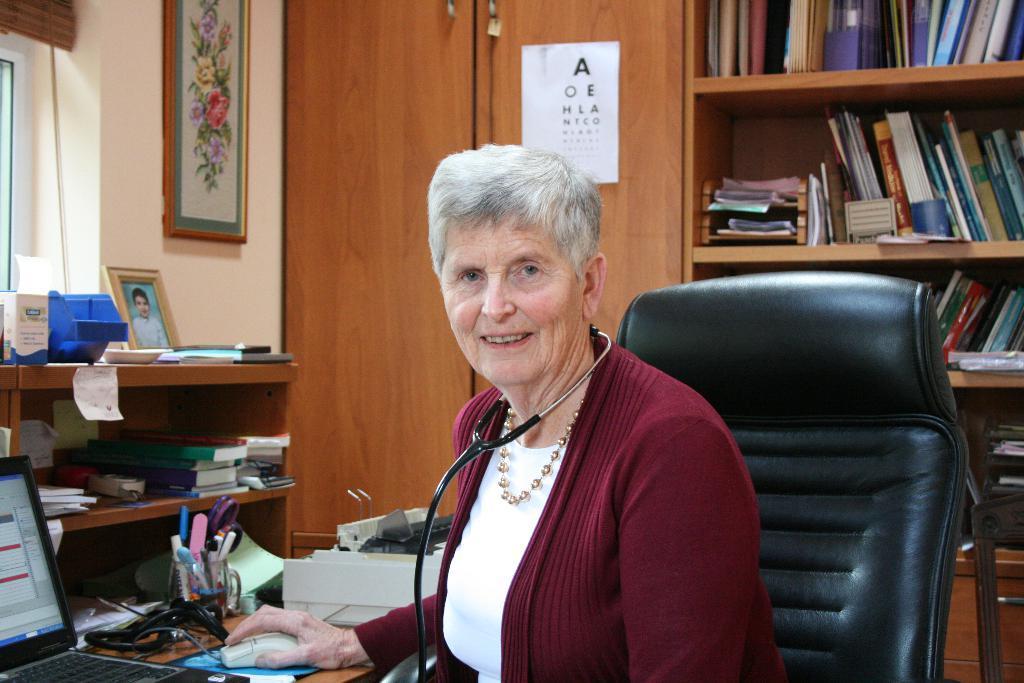In one or two sentences, can you explain what this image depicts? Here we can see a woman sitting on the chair, and in front here is the table and computer and some objects on it, and here are the books, and here is the wall and photo frame on it. 